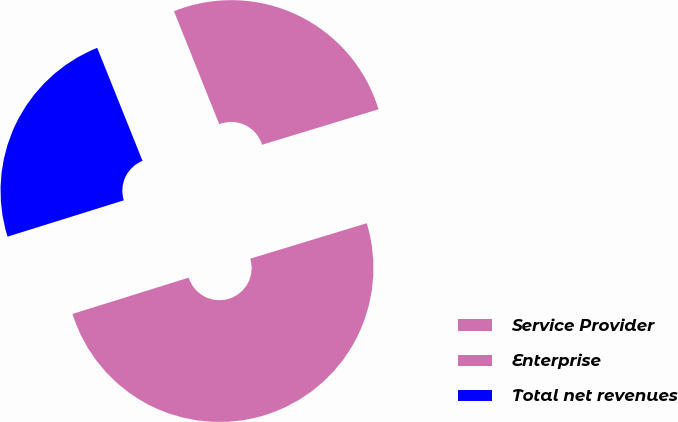<chart> <loc_0><loc_0><loc_500><loc_500><pie_chart><fcel>Service Provider<fcel>Enterprise<fcel>Total net revenues<nl><fcel>26.37%<fcel>49.88%<fcel>23.75%<nl></chart> 